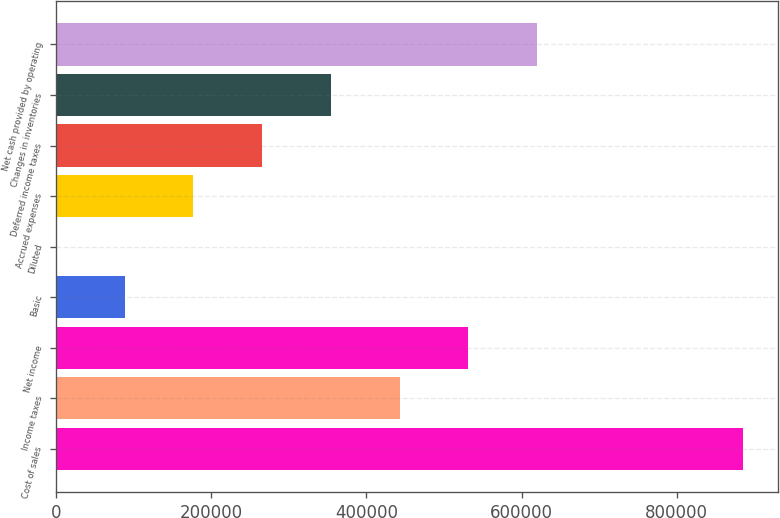Convert chart. <chart><loc_0><loc_0><loc_500><loc_500><bar_chart><fcel>Cost of sales<fcel>Income taxes<fcel>Net income<fcel>Basic<fcel>Diluted<fcel>Accrued expenses<fcel>Deferred income taxes<fcel>Changes in inventories<fcel>Net cash provided by operating<nl><fcel>885562<fcel>442782<fcel>531338<fcel>88557.6<fcel>1.59<fcel>177114<fcel>265670<fcel>354226<fcel>619894<nl></chart> 